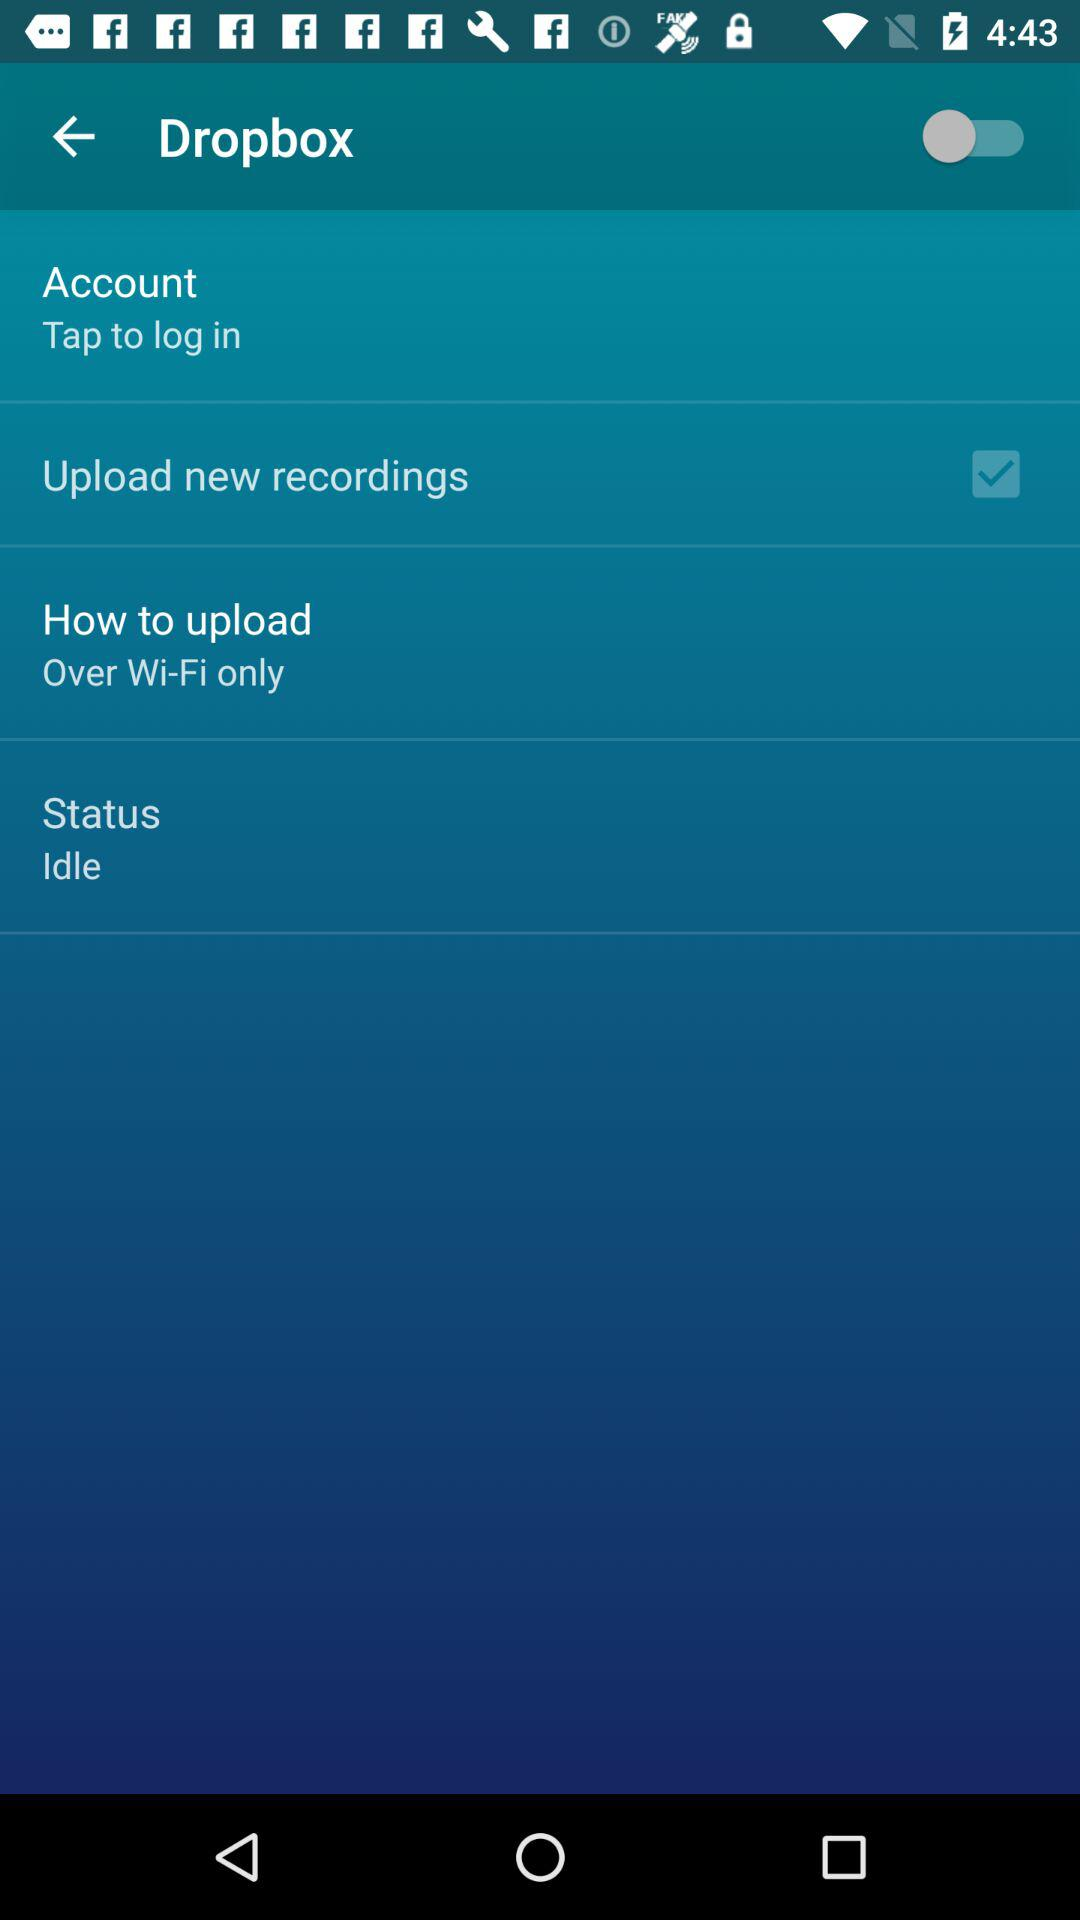What's the setting for "How to upload"? The setting is "Over Wi-Fi only". 